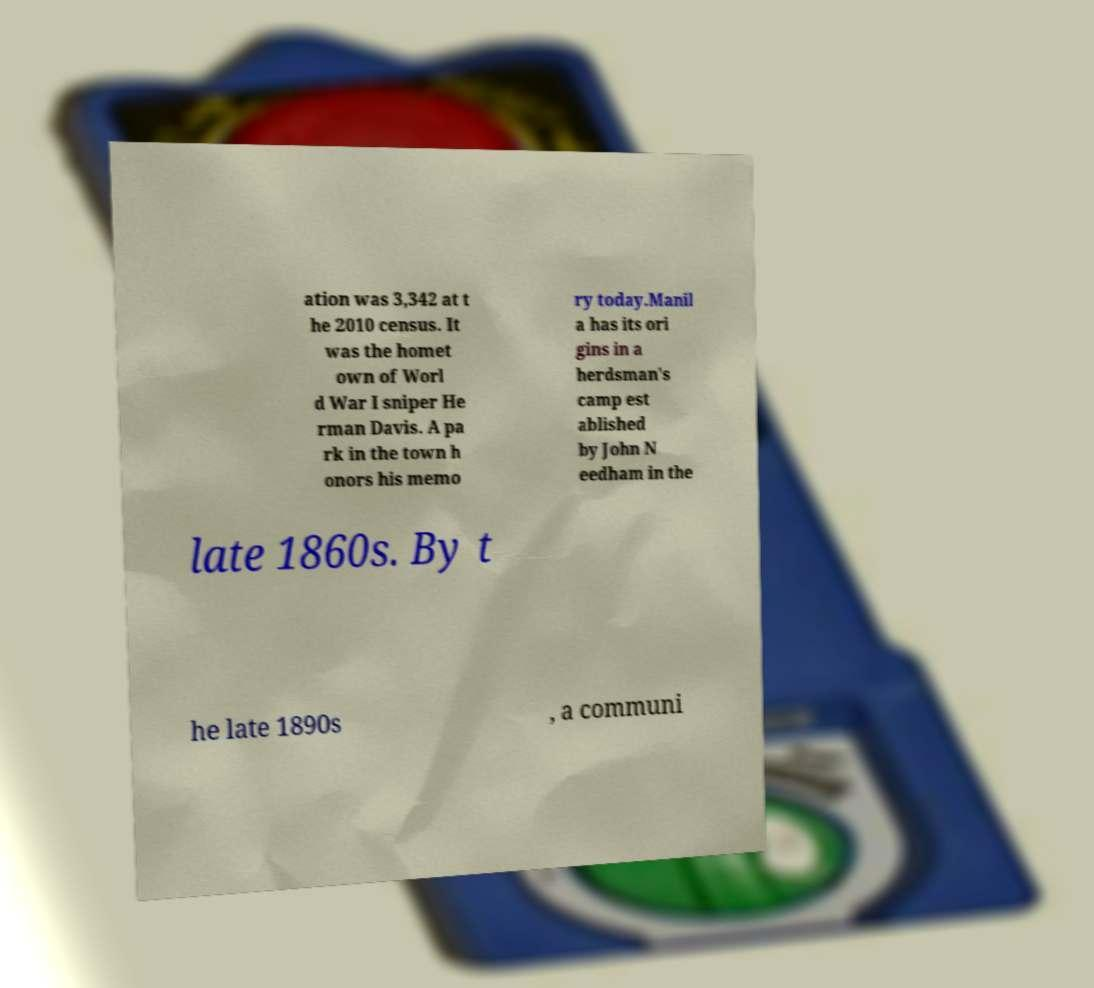Could you assist in decoding the text presented in this image and type it out clearly? ation was 3,342 at t he 2010 census. It was the homet own of Worl d War I sniper He rman Davis. A pa rk in the town h onors his memo ry today.Manil a has its ori gins in a herdsman's camp est ablished by John N eedham in the late 1860s. By t he late 1890s , a communi 